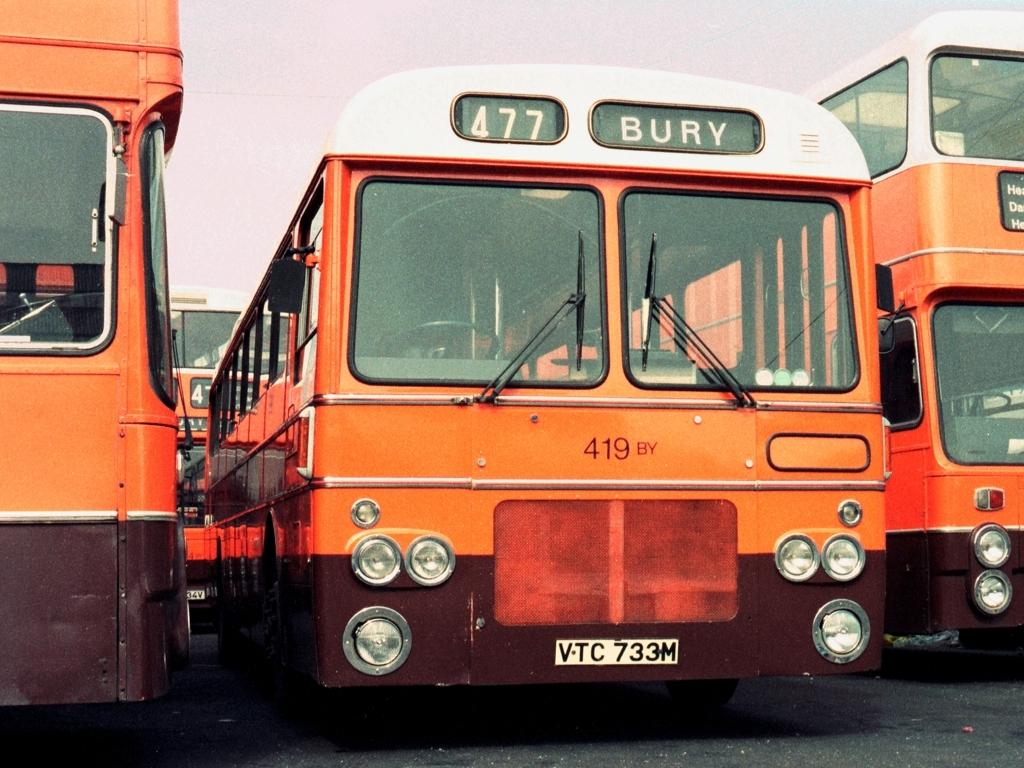What might the number '477' on the bus indicate? The number '477' on the bus is likely a route number indicating which path the bus takes and the destinations it serves, in this case, Bury. 